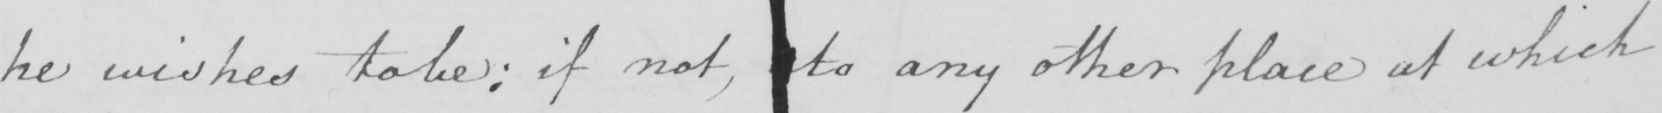What is written in this line of handwriting? he wishes to be :  if not , to any other place at which 